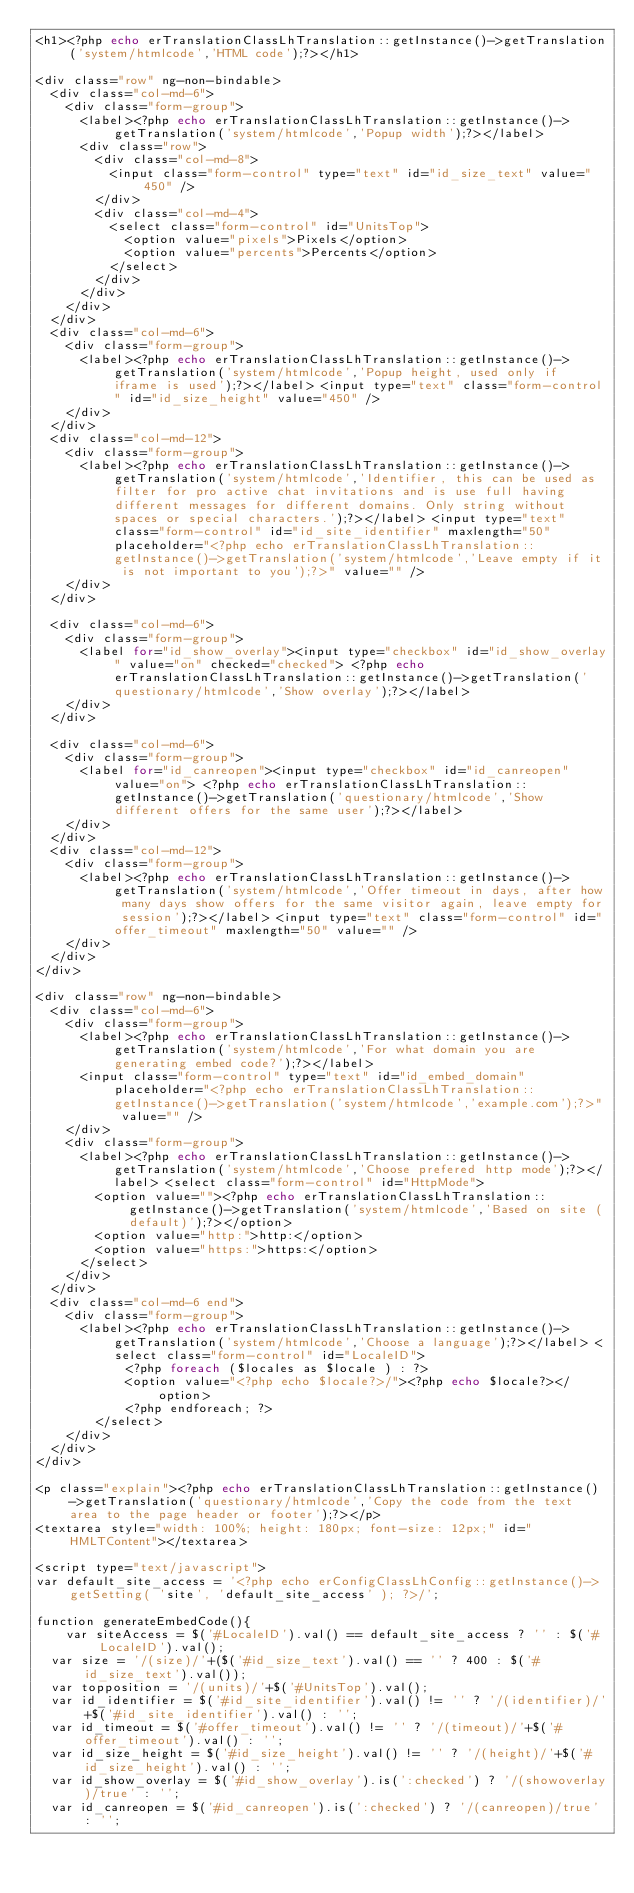<code> <loc_0><loc_0><loc_500><loc_500><_PHP_><h1><?php echo erTranslationClassLhTranslation::getInstance()->getTranslation('system/htmlcode','HTML code');?></h1>

<div class="row" ng-non-bindable>
	<div class="col-md-6">
		<div class="form-group">
			<label><?php echo erTranslationClassLhTranslation::getInstance()->getTranslation('system/htmlcode','Popup width');?></label>
			<div class="row">
				<div class="col-md-8">
					<input class="form-control" type="text" id="id_size_text" value="450" />
				</div>
				<div class="col-md-4">
					<select class="form-control" id="UnitsTop">
						<option value="pixels">Pixels</option>
						<option value="percents">Percents</option>
					</select>
				</div>
			</div>
		</div>
	</div>
	<div class="col-md-6">
		<div class="form-group">
			<label><?php echo erTranslationClassLhTranslation::getInstance()->getTranslation('system/htmlcode','Popup height, used only if iframe is used');?></label> <input type="text" class="form-control" id="id_size_height" value="450" />
		</div>
	</div>
	<div class="col-md-12">
		<div class="form-group">
			<label><?php echo erTranslationClassLhTranslation::getInstance()->getTranslation('system/htmlcode','Identifier, this can be used as filter for pro active chat invitations and is use full having different messages for different domains. Only string without spaces or special characters.');?></label> <input type="text" class="form-control" id="id_site_identifier" maxlength="50" placeholder="<?php echo erTranslationClassLhTranslation::getInstance()->getTranslation('system/htmlcode','Leave empty if it is not important to you');?>" value="" />
		</div>
	</div>

	<div class="col-md-6">
		<div class="form-group">
			<label for="id_show_overlay"><input type="checkbox" id="id_show_overlay" value="on" checked="checked"> <?php echo erTranslationClassLhTranslation::getInstance()->getTranslation('questionary/htmlcode','Show overlay');?></label>
		</div>
	</div>

	<div class="col-md-6">
		<div class="form-group">
			<label for="id_canreopen"><input type="checkbox" id="id_canreopen" value="on"> <?php echo erTranslationClassLhTranslation::getInstance()->getTranslation('questionary/htmlcode','Show different offers for the same user');?></label>
		</div>
	</div>
	<div class="col-md-12">
		<div class="form-group">
			<label><?php echo erTranslationClassLhTranslation::getInstance()->getTranslation('system/htmlcode','Offer timeout in days, after how many days show offers for the same visitor again, leave empty for session');?></label> <input type="text" class="form-control" id="offer_timeout" maxlength="50" value="" />
		</div>
	</div>
</div>

<div class="row" ng-non-bindable>
	<div class="col-md-6">
		<div class="form-group">
			<label><?php echo erTranslationClassLhTranslation::getInstance()->getTranslation('system/htmlcode','For what domain you are generating embed code?');?></label> 
			<input class="form-control" type="text" id="id_embed_domain" placeholder="<?php echo erTranslationClassLhTranslation::getInstance()->getTranslation('system/htmlcode','example.com');?>" value="" /> 
		</div>	
		<div class="form-group">
			<label><?php echo erTranslationClassLhTranslation::getInstance()->getTranslation('system/htmlcode','Choose prefered http mode');?></label> <select class="form-control" id="HttpMode">
				<option value=""><?php echo erTranslationClassLhTranslation::getInstance()->getTranslation('system/htmlcode','Based on site (default)');?></option>
				<option value="http:">http:</option>
				<option value="https:">https:</option>
			</select>
		</div>
	</div>
	<div class="col-md-6 end">
		<div class="form-group">
			<label><?php echo erTranslationClassLhTranslation::getInstance()->getTranslation('system/htmlcode','Choose a language');?></label> <select class="form-control" id="LocaleID">
            <?php foreach ($locales as $locale ) : ?>
            <option value="<?php echo $locale?>/"><?php echo $locale?></option>
            <?php endforeach; ?>
        </select>
		</div>
	</div>
</div>

<p class="explain"><?php echo erTranslationClassLhTranslation::getInstance()->getTranslation('questionary/htmlcode','Copy the code from the text area to the page header or footer');?></p>
<textarea style="width: 100%; height: 180px; font-size: 12px;" id="HMLTContent"></textarea>

<script type="text/javascript">
var default_site_access = '<?php echo erConfigClassLhConfig::getInstance()->getSetting( 'site', 'default_site_access' ); ?>/';

function generateEmbedCode(){
    var siteAccess = $('#LocaleID').val() == default_site_access ? '' : $('#LocaleID').val();
	var size = '/(size)/'+($('#id_size_text').val() == '' ? 400 : $('#id_size_text').val());
	var topposition = '/(units)/'+$('#UnitsTop').val();
	var id_identifier = $('#id_site_identifier').val() != '' ? '/(identifier)/'+$('#id_site_identifier').val() : '';
	var id_timeout = $('#offer_timeout').val() != '' ? '/(timeout)/'+$('#offer_timeout').val() : '';
	var id_size_height = $('#id_size_height').val() != '' ? '/(height)/'+$('#id_size_height').val() : '';
	var id_show_overlay = $('#id_show_overlay').is(':checked') ? '/(showoverlay)/true' : '';
	var id_canreopen = $('#id_canreopen').is(':checked') ? '/(canreopen)/true' : '';</code> 